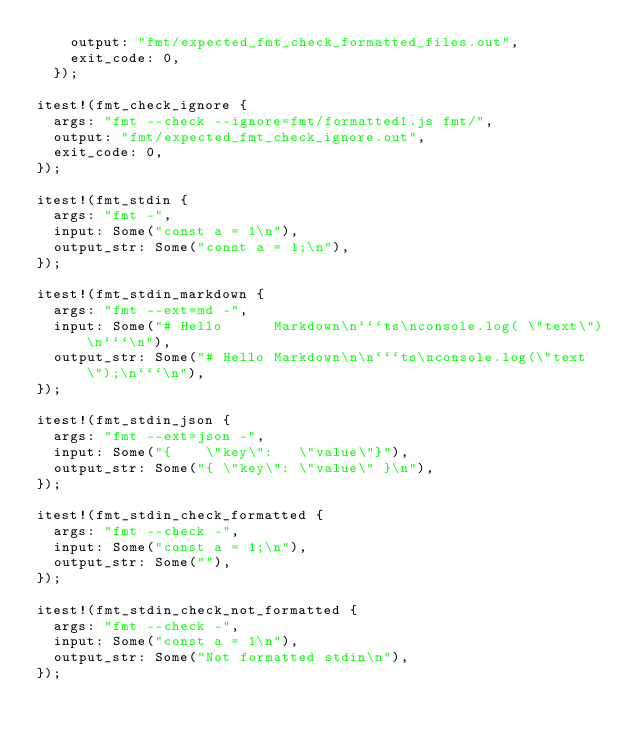<code> <loc_0><loc_0><loc_500><loc_500><_Rust_>    output: "fmt/expected_fmt_check_formatted_files.out",
    exit_code: 0,
  });

itest!(fmt_check_ignore {
  args: "fmt --check --ignore=fmt/formatted1.js fmt/",
  output: "fmt/expected_fmt_check_ignore.out",
  exit_code: 0,
});

itest!(fmt_stdin {
  args: "fmt -",
  input: Some("const a = 1\n"),
  output_str: Some("const a = 1;\n"),
});

itest!(fmt_stdin_markdown {
  args: "fmt --ext=md -",
  input: Some("# Hello      Markdown\n```ts\nconsole.log( \"text\")\n```\n"),
  output_str: Some("# Hello Markdown\n\n```ts\nconsole.log(\"text\");\n```\n"),
});

itest!(fmt_stdin_json {
  args: "fmt --ext=json -",
  input: Some("{    \"key\":   \"value\"}"),
  output_str: Some("{ \"key\": \"value\" }\n"),
});

itest!(fmt_stdin_check_formatted {
  args: "fmt --check -",
  input: Some("const a = 1;\n"),
  output_str: Some(""),
});

itest!(fmt_stdin_check_not_formatted {
  args: "fmt --check -",
  input: Some("const a = 1\n"),
  output_str: Some("Not formatted stdin\n"),
});
</code> 